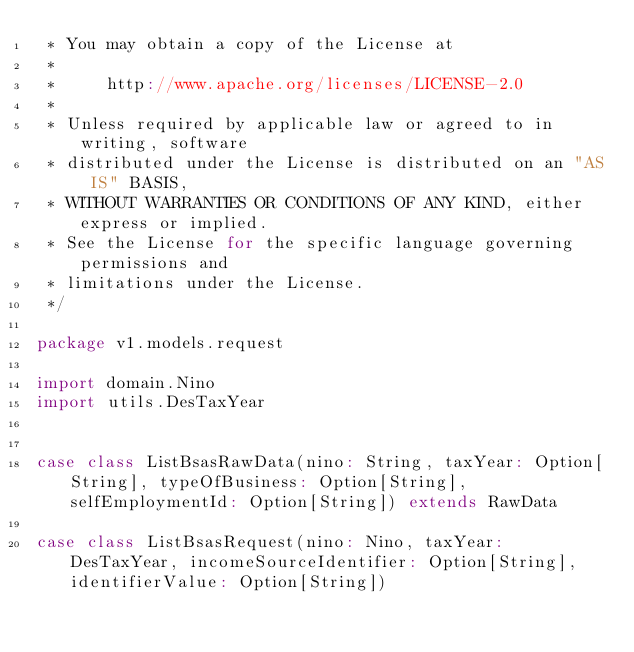<code> <loc_0><loc_0><loc_500><loc_500><_Scala_> * You may obtain a copy of the License at
 *
 *     http://www.apache.org/licenses/LICENSE-2.0
 *
 * Unless required by applicable law or agreed to in writing, software
 * distributed under the License is distributed on an "AS IS" BASIS,
 * WITHOUT WARRANTIES OR CONDITIONS OF ANY KIND, either express or implied.
 * See the License for the specific language governing permissions and
 * limitations under the License.
 */

package v1.models.request

import domain.Nino
import utils.DesTaxYear


case class ListBsasRawData(nino: String, taxYear: Option[String], typeOfBusiness: Option[String], selfEmploymentId: Option[String]) extends RawData

case class ListBsasRequest(nino: Nino, taxYear: DesTaxYear, incomeSourceIdentifier: Option[String], identifierValue: Option[String])
</code> 